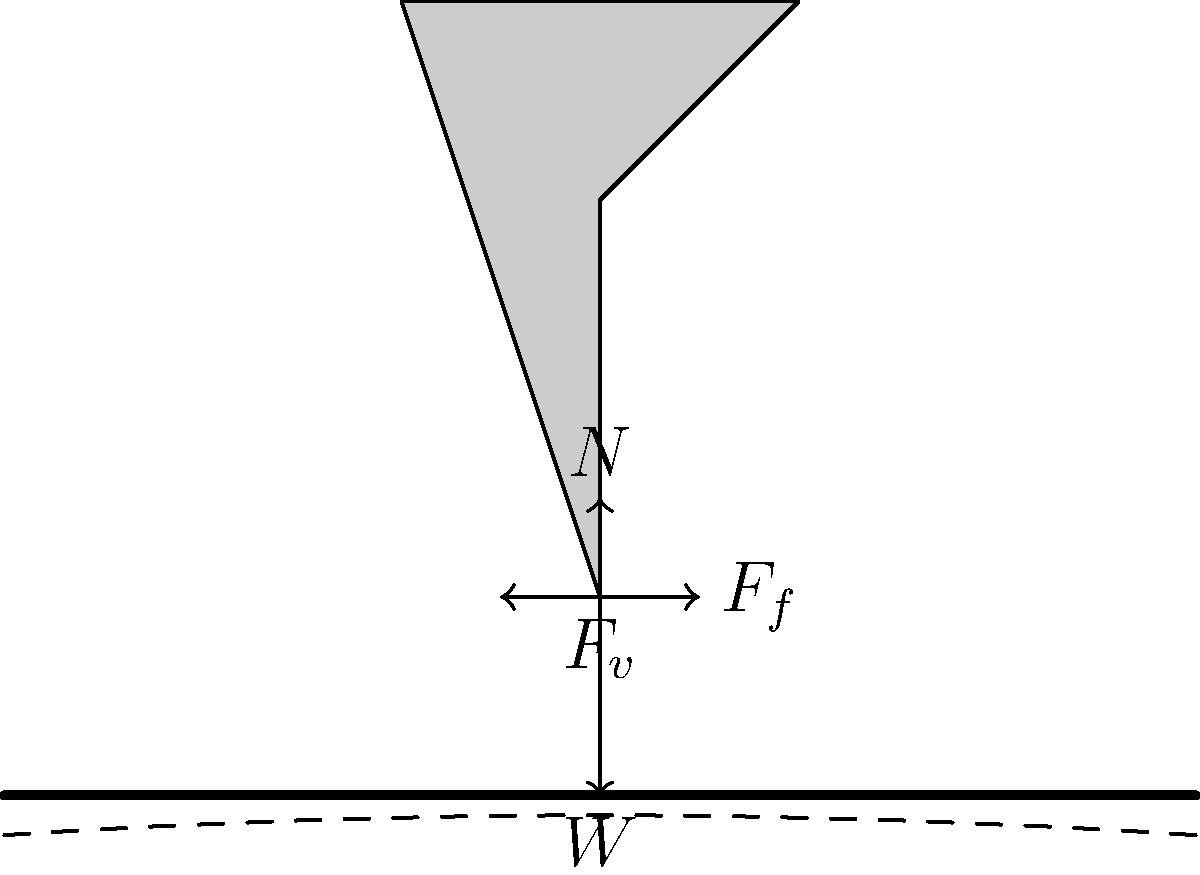As a country artist performing on a vibrating stage platform, you need to understand the forces acting on your body to maintain balance. Consider the force diagram shown, where $W$ is your weight, $N$ is the normal force, $F_f$ is the friction force, and $F_v$ is the vibration force. If the coefficient of static friction between your boots and the stage is $\mu_s = 0.8$, what is the maximum horizontal vibration force $F_v$ that you can withstand without slipping, given that your weight is 700 N? To solve this problem, we'll follow these steps:

1) First, we need to understand the forces acting on the performer:
   - Weight ($W$) acts downward
   - Normal force ($N$) acts upward
   - Friction force ($F_f$) acts horizontally to resist motion
   - Vibration force ($F_v$) acts horizontally

2) In the vertical direction, the forces are balanced when not slipping:
   $N = W = 700 \text{ N}$

3) The maximum friction force is given by:
   $F_{f,max} = \mu_s N$

4) Substituting the values:
   $F_{f,max} = 0.8 \times 700 \text{ N} = 560 \text{ N}$

5) The performer will start to slip when the vibration force exceeds the maximum friction force. Therefore, the maximum vibration force that can be withstood is equal to the maximum friction force:

   $F_{v,max} = F_{f,max} = 560 \text{ N}$

Thus, the maximum horizontal vibration force that can be withstood without slipping is 560 N.
Answer: 560 N 